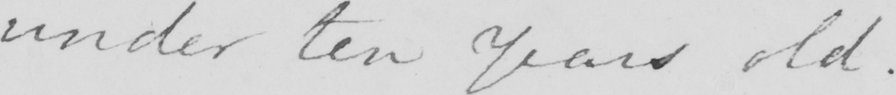Please provide the text content of this handwritten line. under ten years old . 